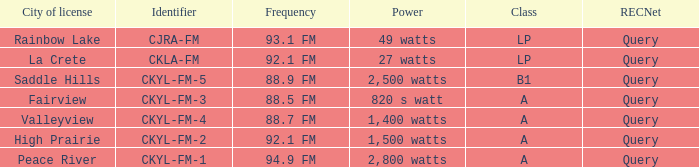What is the City of license with a 88.7 fm frequency Valleyview. 